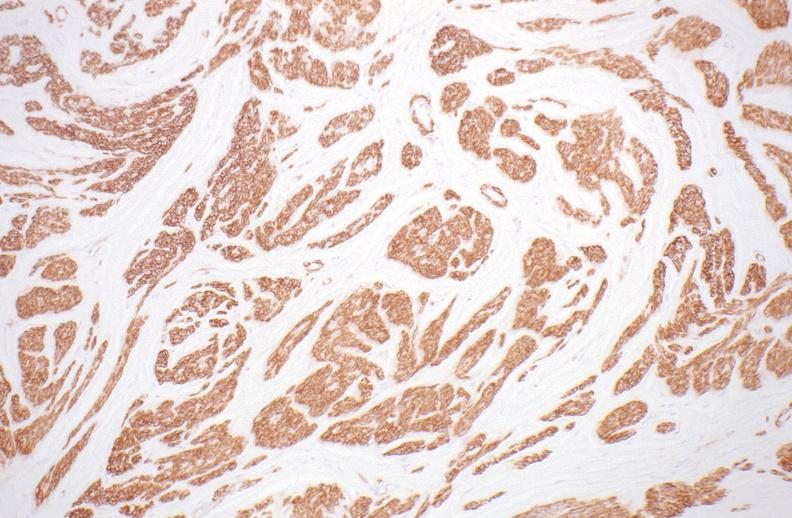what stain?
Answer the question using a single word or phrase. Alpha smooth muscle actin immunohistochemical 